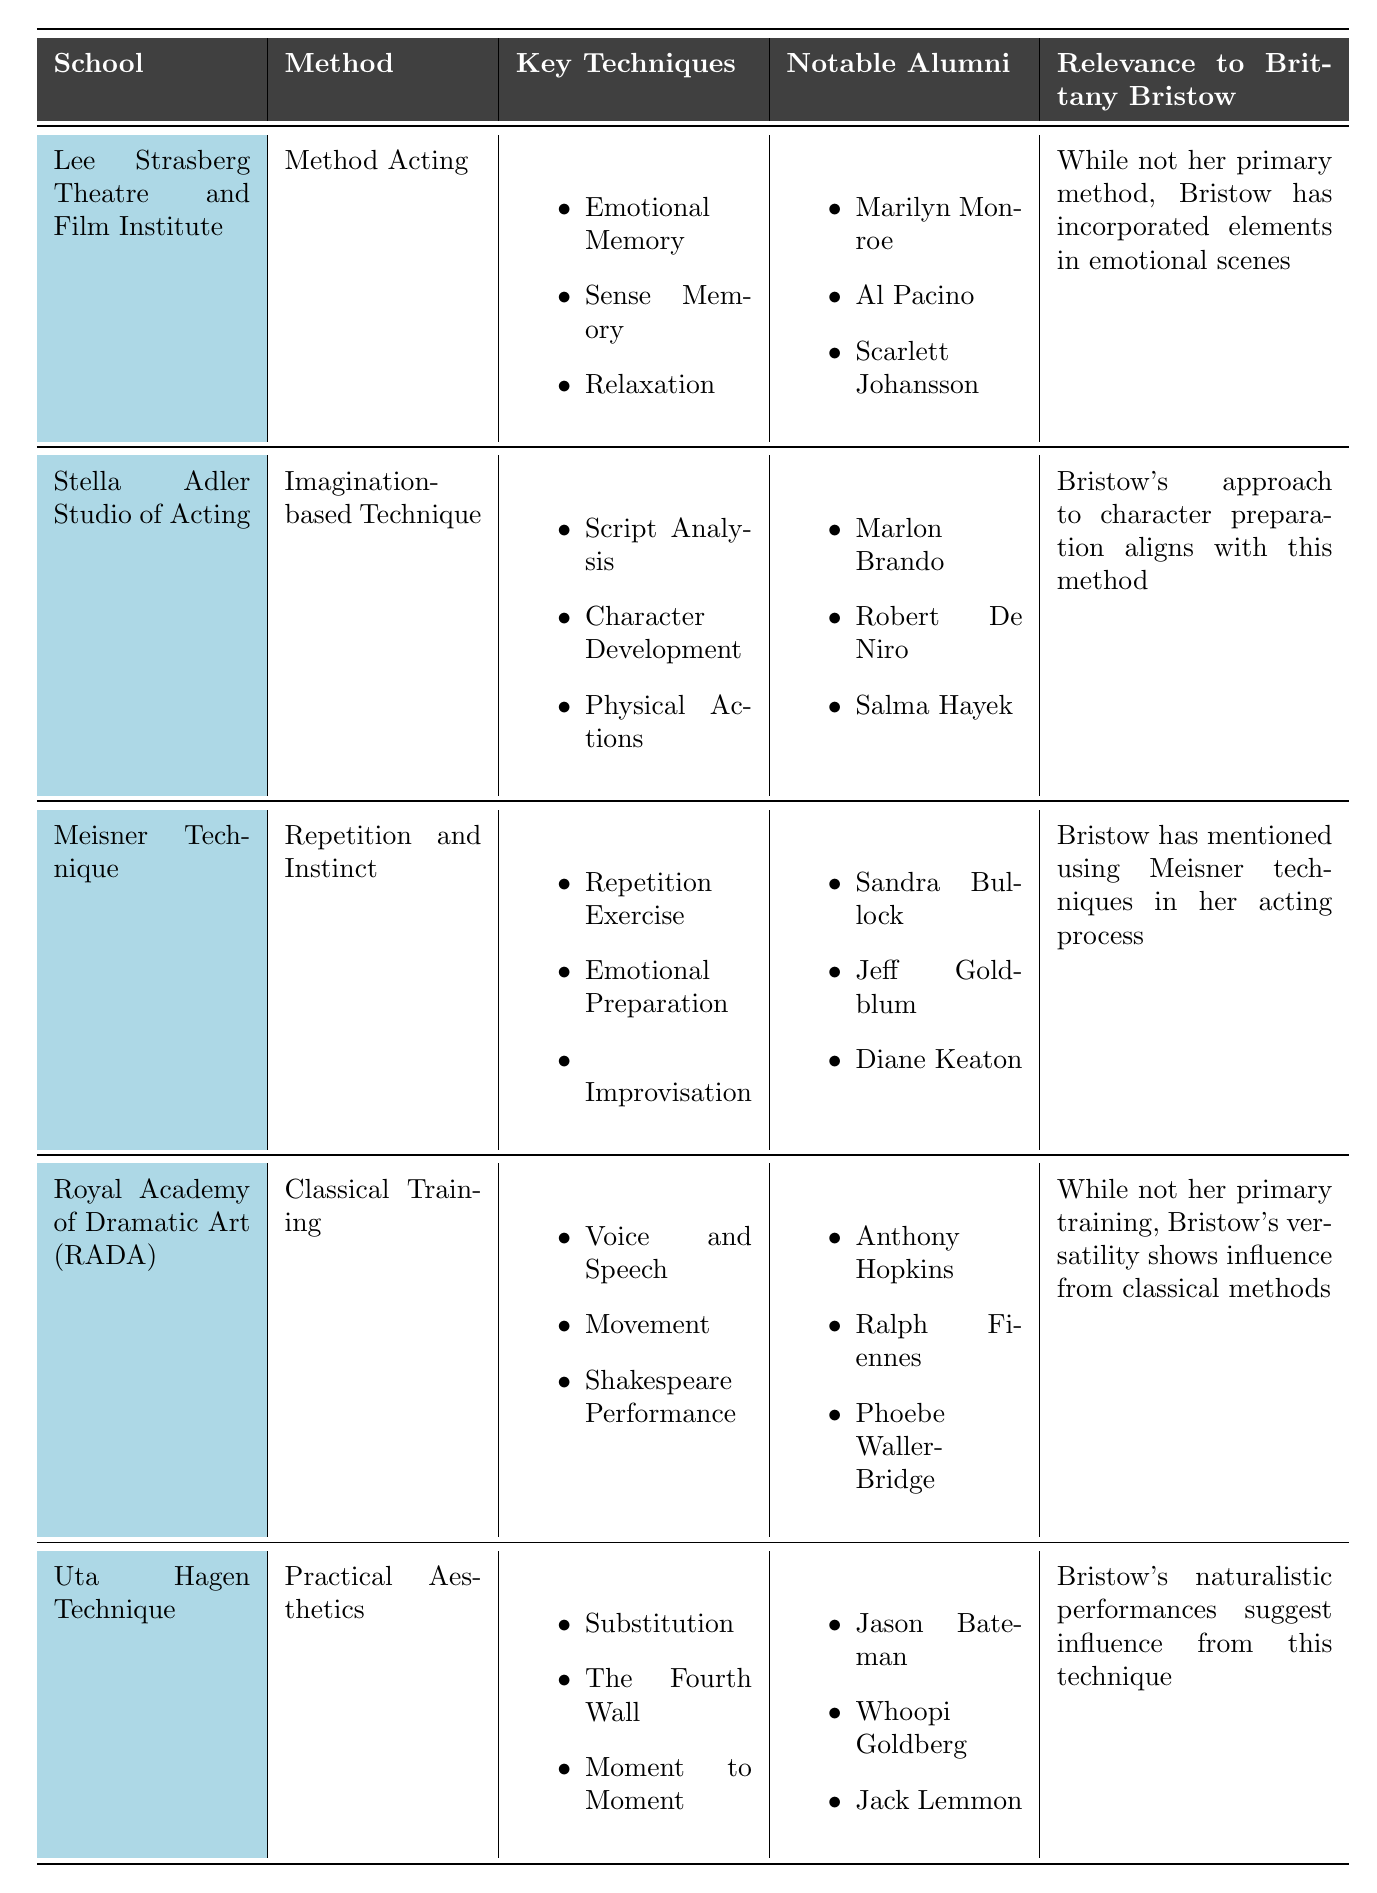What is the key technique associated with Method Acting? The method linked with the Lee Strasberg Theatre and Film Institute is Method Acting, which includes Emotional Memory, Sense Memory, and Relaxation as key techniques.
Answer: Emotional Memory, Sense Memory, Relaxation Who are some notable alumni of the Stella Adler Studio of Acting? The notable alumni from the Stella Adler Studio of Acting mentioned in the table include Marlon Brando, Robert De Niro, and Salma Hayek.
Answer: Marlon Brando, Robert De Niro, Salma Hayek Is Brittany Bristow primarily trained in Method Acting? The table states that while Bristow has incorporated elements from Method Acting, it is not her primary method.
Answer: No Which acting school has the most high-profile alumni listed? The Meisner Technique lists notable alumni including Sandra Bullock, Jeff Goldblum, and Diane Keaton. The schools have varying acclaim, but the most consistent names commonly recognized in popular culture suggest Meisner Technique as strong in terms of high-profile alumni.
Answer: Meisner Technique How many key techniques are mentioned for the Uta Hagen Technique? The Uta Hagen Technique includes three key techniques: Substitution, The Fourth Wall, and Moment to Moment. Thus, a count of the techniques yields three.
Answer: 3 What relevance do the techniques from the Lee Strasberg Theatre and Film Institute have to Brittany Bristow? According to the table, Brittany Bristow has incorporated elements of Method Acting during emotional scenes, indicating a connection to her work with the Lee Strasberg Theatre and Film Institute.
Answer: Incorporated elements in emotional scenes Which acting method does Brittany Bristow most closely align with based on character preparation? The relevance to Brittany Bristow suggests that her approach to character preparation aligns with the Imagination-based Technique at the Stella Adler Studio of Acting.
Answer: Imagination-based Technique List all methods that include improvisation as a key technique. The Meisner Technique is explicitly stated to include Improvisation as one of its key techniques. So, the answer focuses solely on Meisner Technique for improvisation.
Answer: Meisner Technique What is the relationship between Brittany Bristow's performances and the Uta Hagen Technique? The table indicates that Brittany Bristow's naturalistic performances suggest influence from the Uta Hagen Technique, highlighting a connection between her style and the techniques taught there.
Answer: Suggests influence from this technique Compare the key techniques between Method Acting and Classical Training. Method Acting, associated with the Lee Strasberg Theatre and Film Institute, focuses on Emotional Memory, Sense Memory, and Relaxation. On the other hand, Classical Training includes Voice and Speech, Movement, and Shakespeare Performance, which are distinct from the emotional-focused techniques of Method Acting.
Answer: Different key techniques What is a notable commonality of alumni between the Royal Academy of Dramatic Art and the Uta Hagen Technique? The notable commonality lies in their alumni's strong presence in the acting industry. Both feature celebrated actors; however, the table lists specific names, with the Royal Academy showcasing Anthony Hopkins, Ralph Fiennes, and Phoebe Waller-Bridge, and Uta Hagen including Jason Bateman and Whoopi Goldberg, showcasing elite status, making them both significant but exhibiting different specific alumni correlations.
Answer: Both have prominent alumni, but different names 